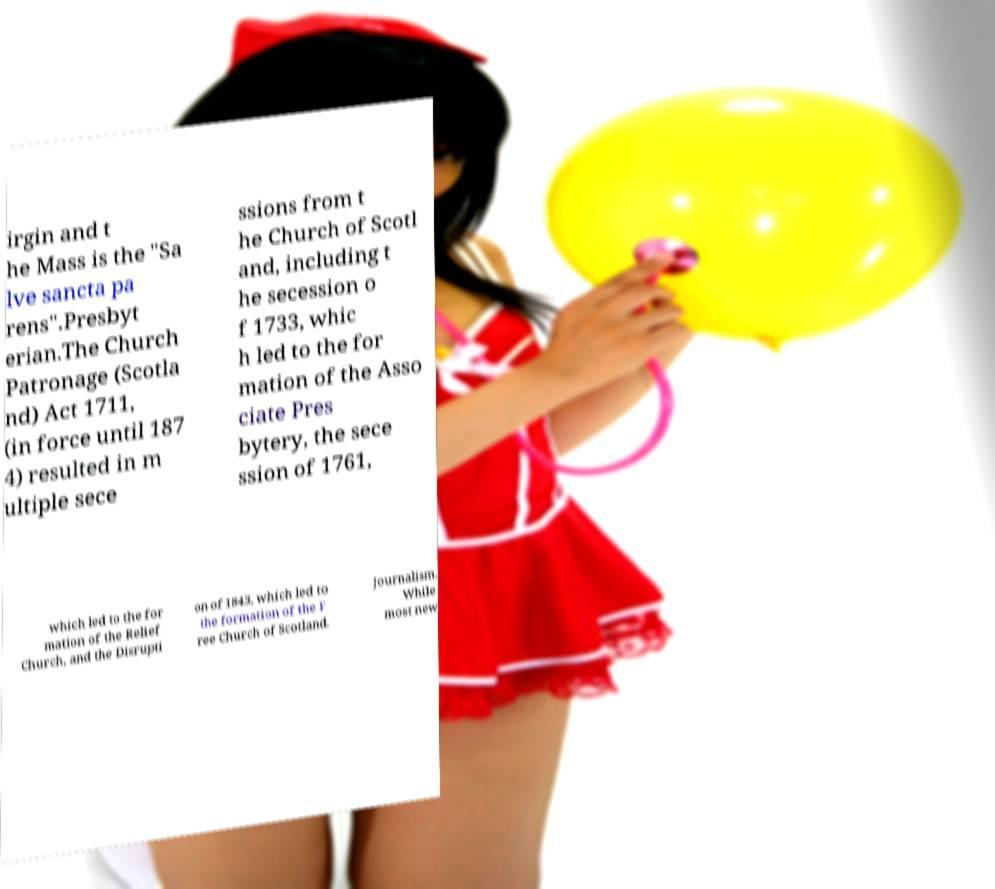I need the written content from this picture converted into text. Can you do that? irgin and t he Mass is the "Sa lve sancta pa rens".Presbyt erian.The Church Patronage (Scotla nd) Act 1711, (in force until 187 4) resulted in m ultiple sece ssions from t he Church of Scotl and, including t he secession o f 1733, whic h led to the for mation of the Asso ciate Pres bytery, the sece ssion of 1761, which led to the for mation of the Relief Church, and the Disrupti on of 1843, which led to the formation of the F ree Church of Scotland. Journalism. While most new 